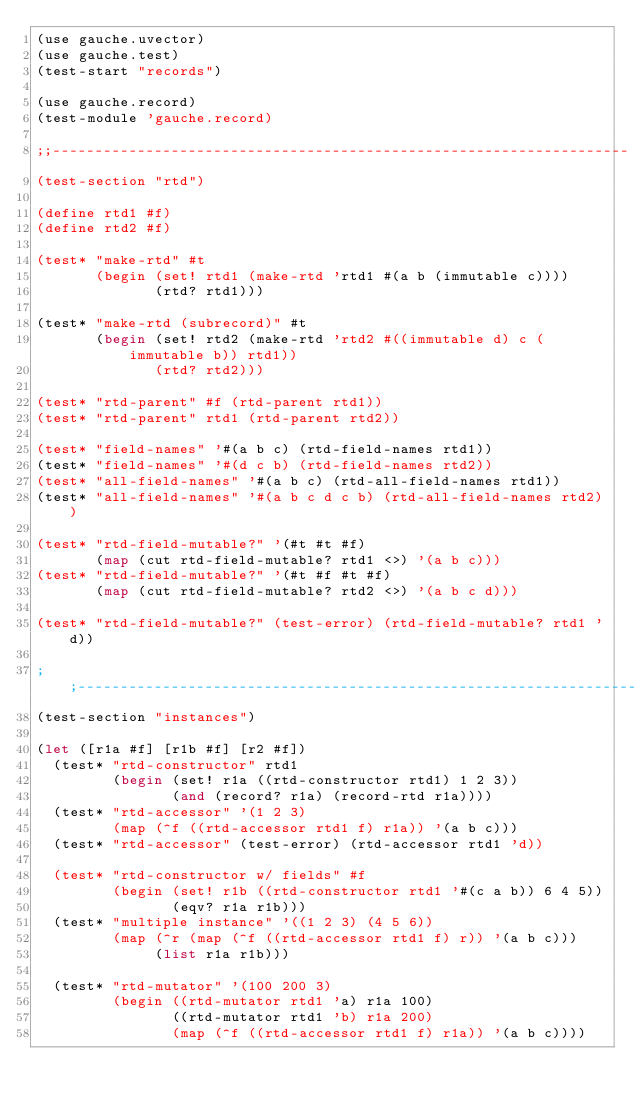Convert code to text. <code><loc_0><loc_0><loc_500><loc_500><_Scheme_>(use gauche.uvector)
(use gauche.test)
(test-start "records")

(use gauche.record)
(test-module 'gauche.record)

;;--------------------------------------------------------------------
(test-section "rtd")

(define rtd1 #f)
(define rtd2 #f)

(test* "make-rtd" #t
       (begin (set! rtd1 (make-rtd 'rtd1 #(a b (immutable c))))
              (rtd? rtd1)))

(test* "make-rtd (subrecord)" #t
       (begin (set! rtd2 (make-rtd 'rtd2 #((immutable d) c (immutable b)) rtd1))
              (rtd? rtd2)))

(test* "rtd-parent" #f (rtd-parent rtd1))
(test* "rtd-parent" rtd1 (rtd-parent rtd2))

(test* "field-names" '#(a b c) (rtd-field-names rtd1))
(test* "field-names" '#(d c b) (rtd-field-names rtd2))
(test* "all-field-names" '#(a b c) (rtd-all-field-names rtd1))
(test* "all-field-names" '#(a b c d c b) (rtd-all-field-names rtd2))

(test* "rtd-field-mutable?" '(#t #t #f)
       (map (cut rtd-field-mutable? rtd1 <>) '(a b c)))
(test* "rtd-field-mutable?" '(#t #f #t #f)
       (map (cut rtd-field-mutable? rtd2 <>) '(a b c d)))

(test* "rtd-field-mutable?" (test-error) (rtd-field-mutable? rtd1 'd))

;;--------------------------------------------------------------------
(test-section "instances")

(let ([r1a #f] [r1b #f] [r2 #f])
  (test* "rtd-constructor" rtd1
         (begin (set! r1a ((rtd-constructor rtd1) 1 2 3))
                (and (record? r1a) (record-rtd r1a))))
  (test* "rtd-accessor" '(1 2 3)
         (map (^f ((rtd-accessor rtd1 f) r1a)) '(a b c)))
  (test* "rtd-accessor" (test-error) (rtd-accessor rtd1 'd))

  (test* "rtd-constructor w/ fields" #f
         (begin (set! r1b ((rtd-constructor rtd1 '#(c a b)) 6 4 5))
                (eqv? r1a r1b)))
  (test* "multiple instance" '((1 2 3) (4 5 6))
         (map (^r (map (^f ((rtd-accessor rtd1 f) r)) '(a b c)))
              (list r1a r1b)))

  (test* "rtd-mutator" '(100 200 3)
         (begin ((rtd-mutator rtd1 'a) r1a 100)
                ((rtd-mutator rtd1 'b) r1a 200)
                (map (^f ((rtd-accessor rtd1 f) r1a)) '(a b c))))
</code> 